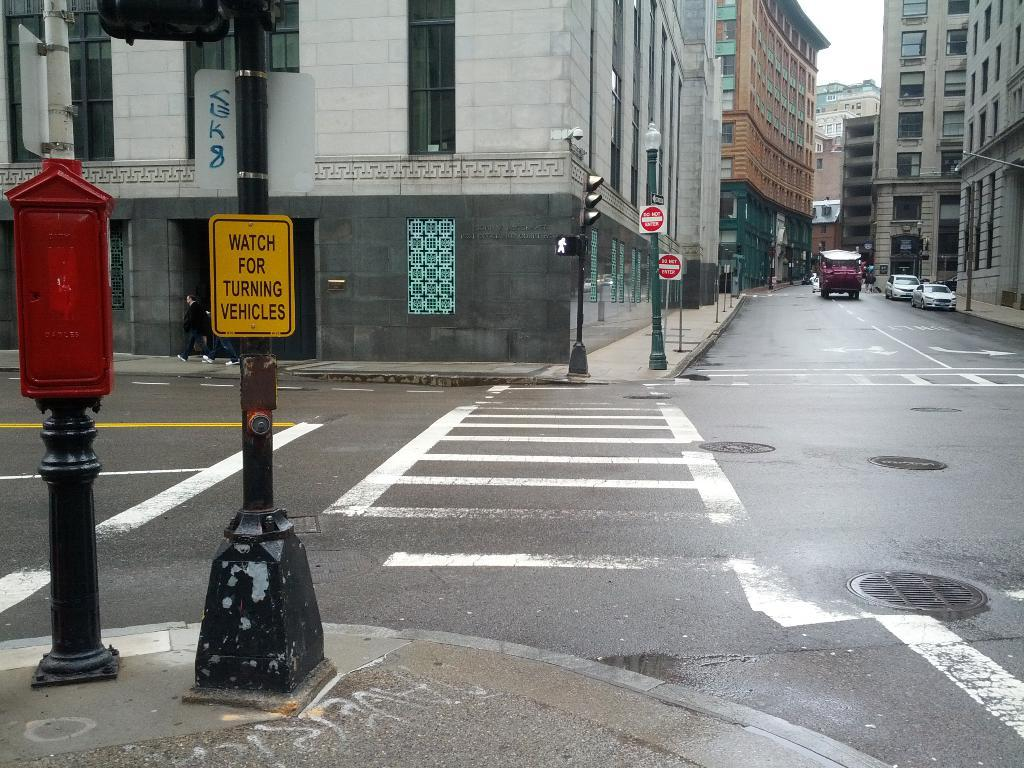Provide a one-sentence caption for the provided image. A sign instructs pedestrians to watch for turning vehicles. 